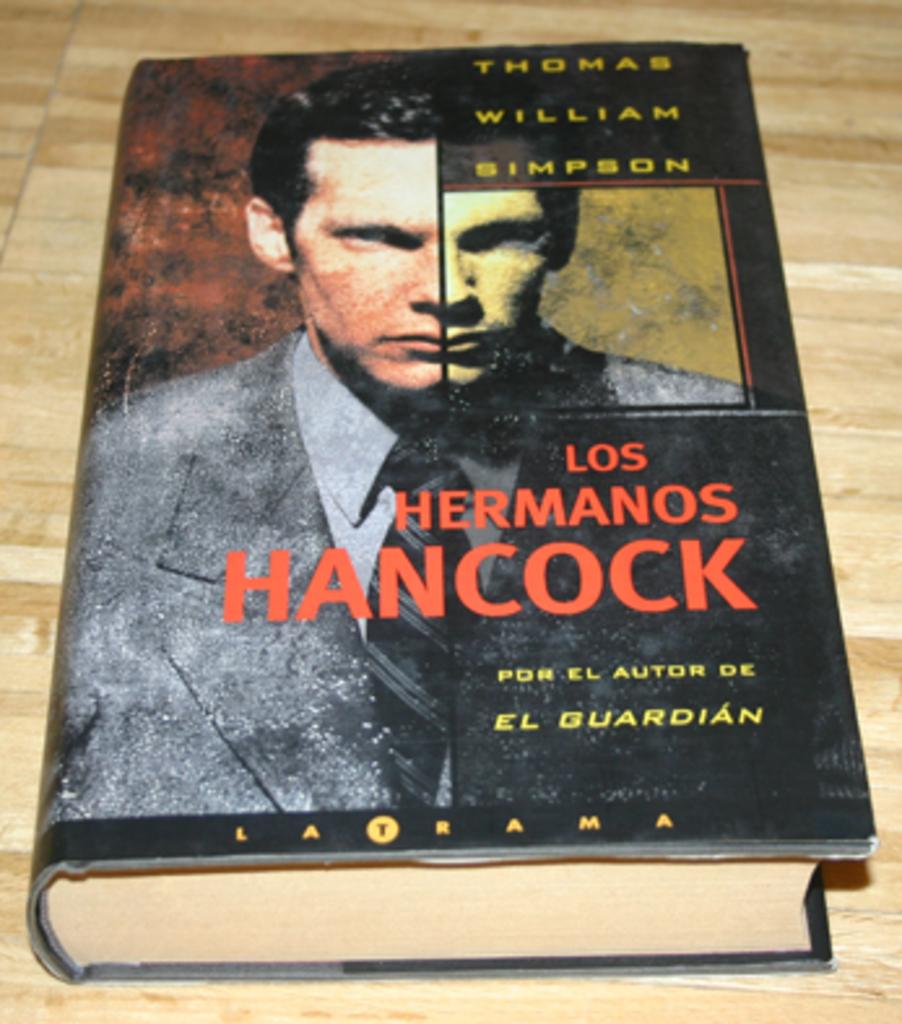Who wrote this book?
Your answer should be compact. Thomas william simpson. 